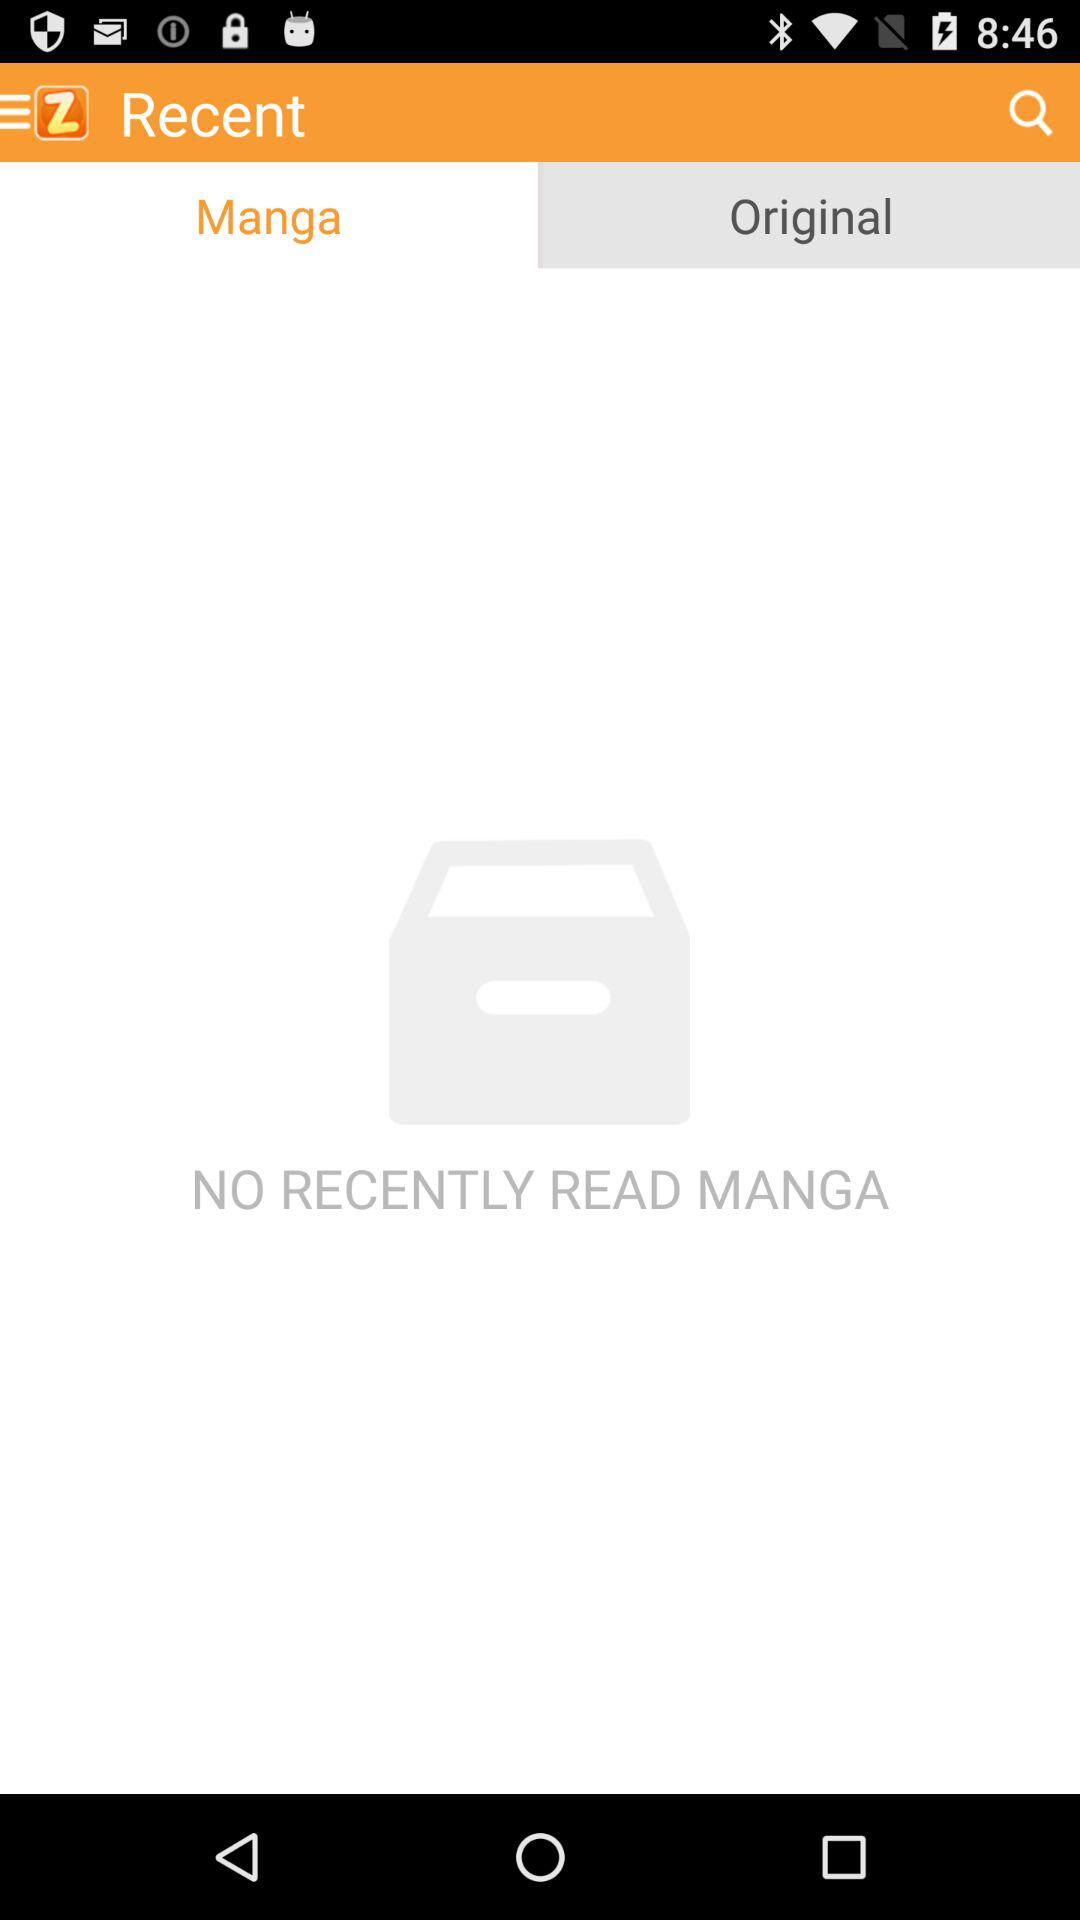Which tab is selected? The selected tab is "Manga". 